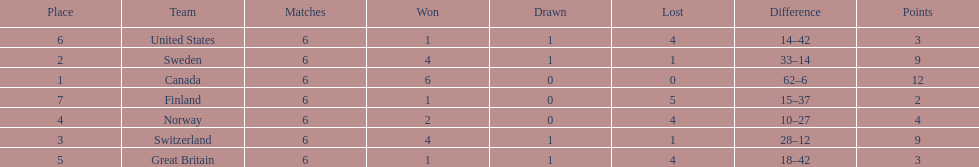Which country's team came in last place during the 1951 world ice hockey championships? Finland. 